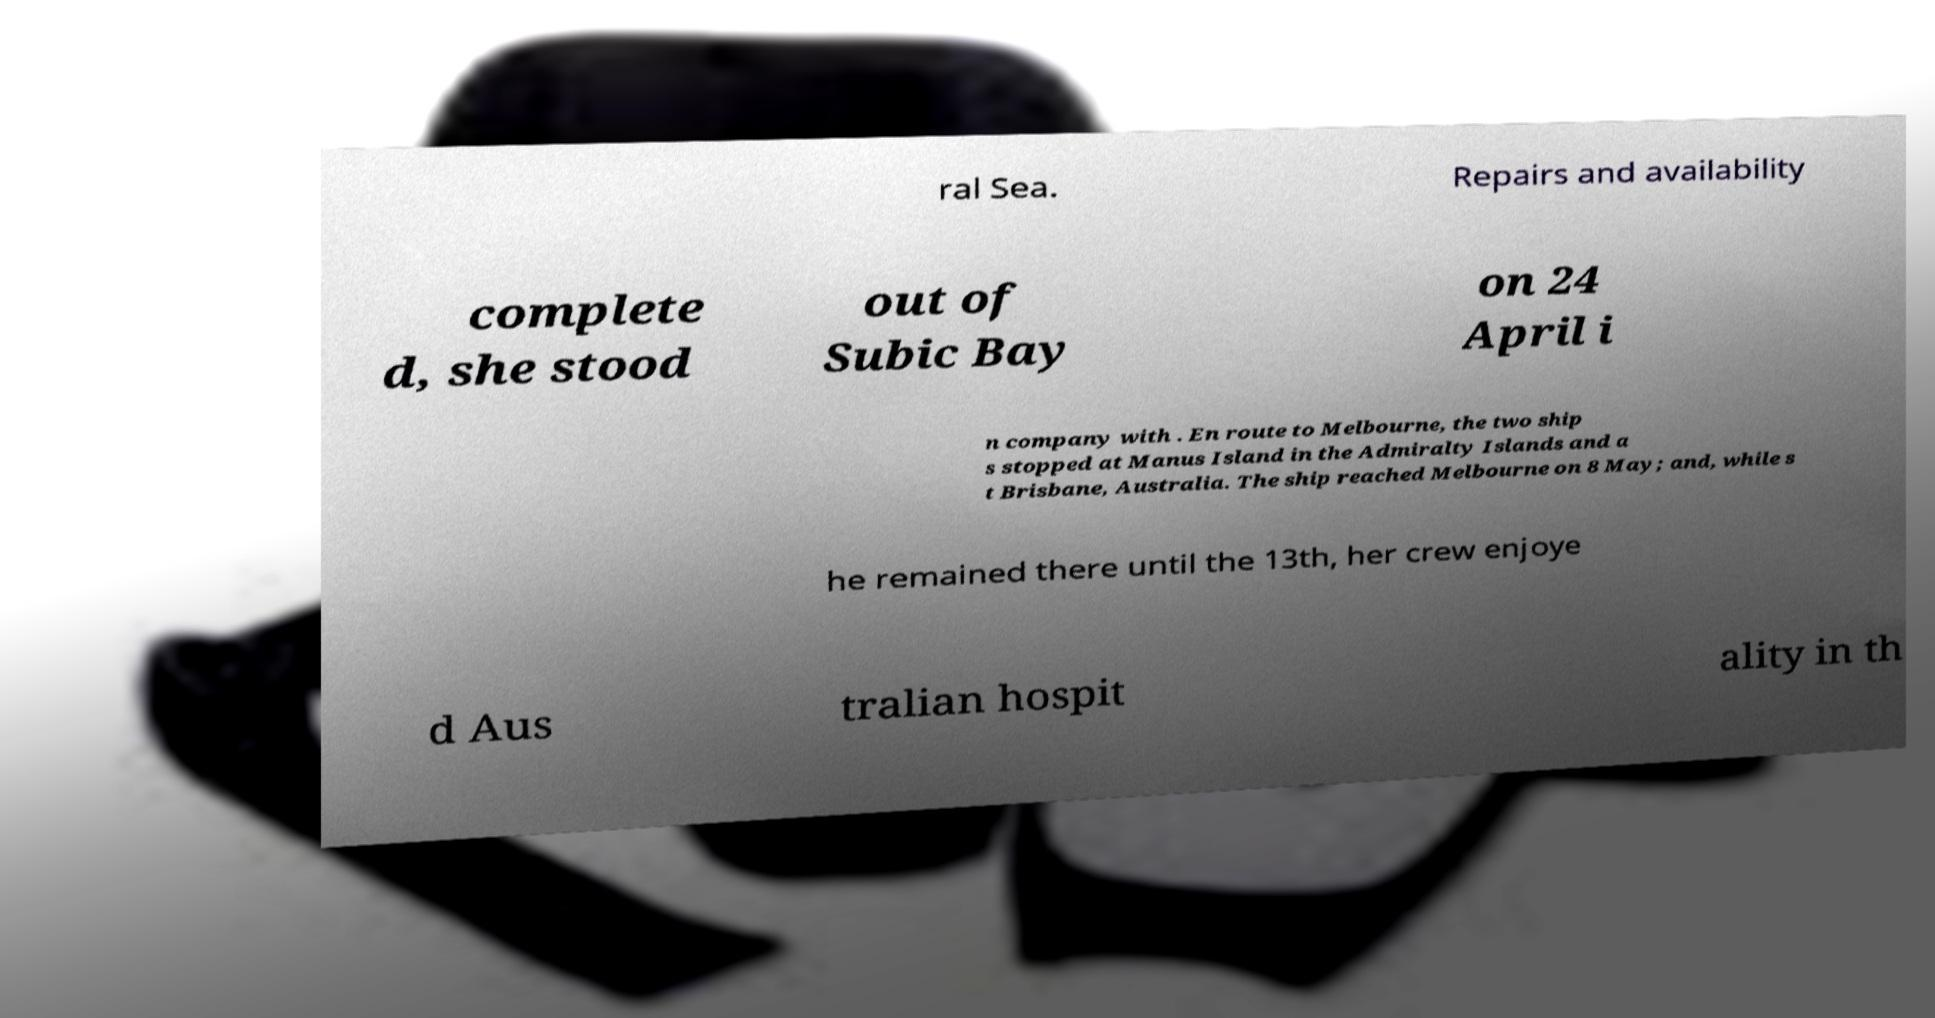What messages or text are displayed in this image? I need them in a readable, typed format. ral Sea. Repairs and availability complete d, she stood out of Subic Bay on 24 April i n company with . En route to Melbourne, the two ship s stopped at Manus Island in the Admiralty Islands and a t Brisbane, Australia. The ship reached Melbourne on 8 May; and, while s he remained there until the 13th, her crew enjoye d Aus tralian hospit ality in th 